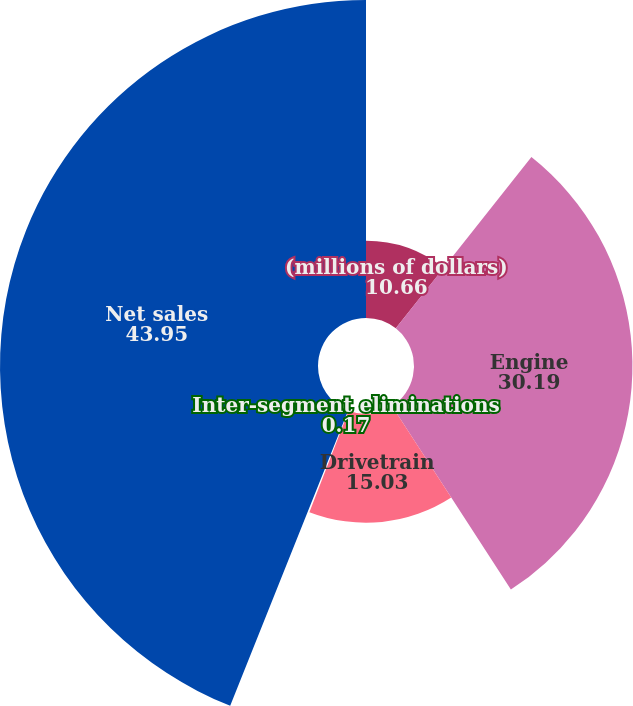Convert chart to OTSL. <chart><loc_0><loc_0><loc_500><loc_500><pie_chart><fcel>(millions of dollars)<fcel>Engine<fcel>Drivetrain<fcel>Inter-segment eliminations<fcel>Net sales<nl><fcel>10.66%<fcel>30.19%<fcel>15.03%<fcel>0.17%<fcel>43.95%<nl></chart> 